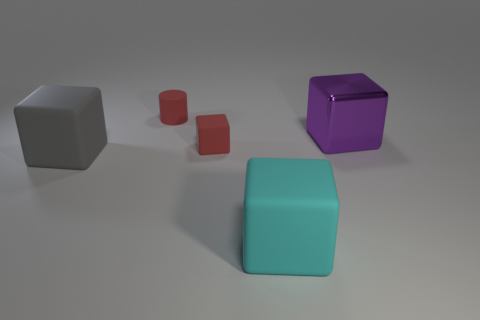Add 1 matte objects. How many objects exist? 6 Subtract all blocks. How many objects are left? 1 Add 3 small red cylinders. How many small red cylinders are left? 4 Add 5 large purple matte spheres. How many large purple matte spheres exist? 5 Subtract 0 green cubes. How many objects are left? 5 Subtract all red cylinders. Subtract all yellow balls. How many objects are left? 4 